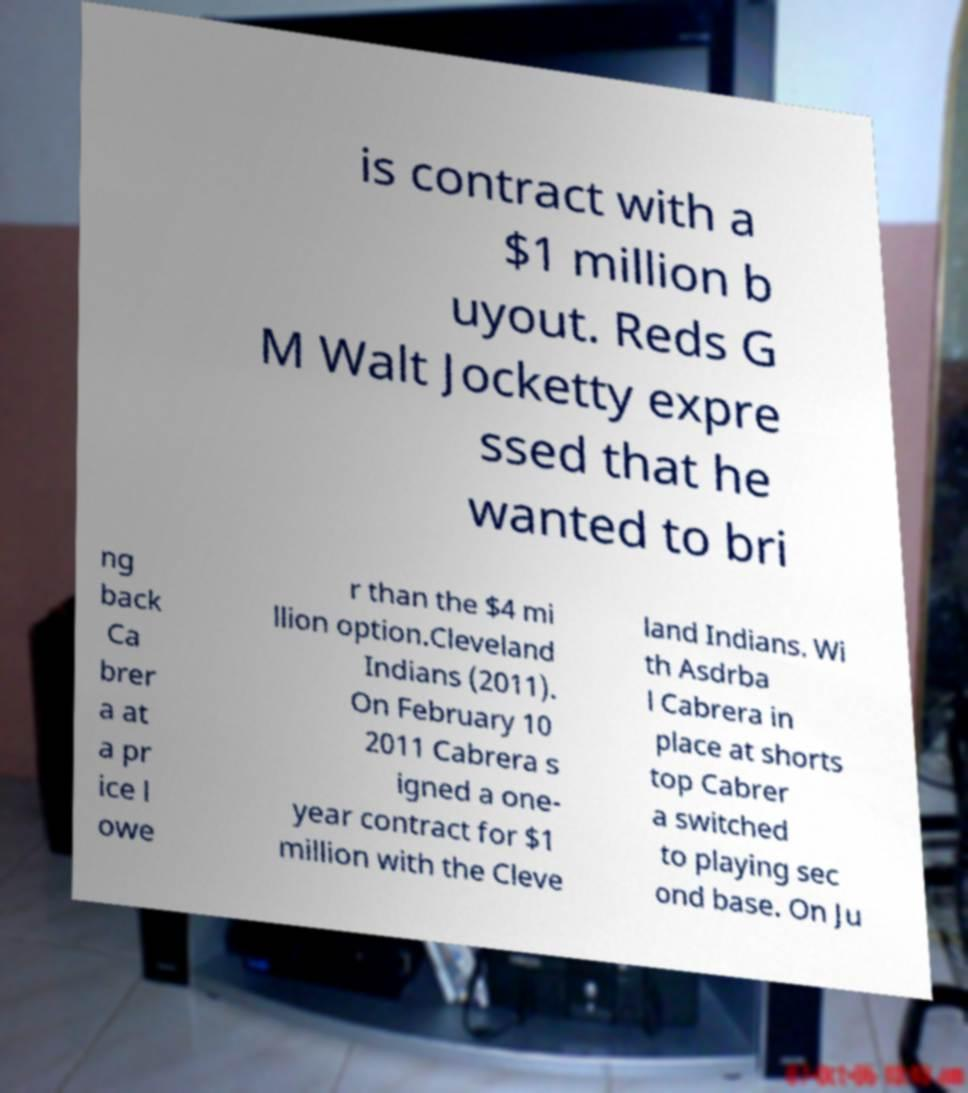For documentation purposes, I need the text within this image transcribed. Could you provide that? is contract with a $1 million b uyout. Reds G M Walt Jocketty expre ssed that he wanted to bri ng back Ca brer a at a pr ice l owe r than the $4 mi llion option.Cleveland Indians (2011). On February 10 2011 Cabrera s igned a one- year contract for $1 million with the Cleve land Indians. Wi th Asdrba l Cabrera in place at shorts top Cabrer a switched to playing sec ond base. On Ju 